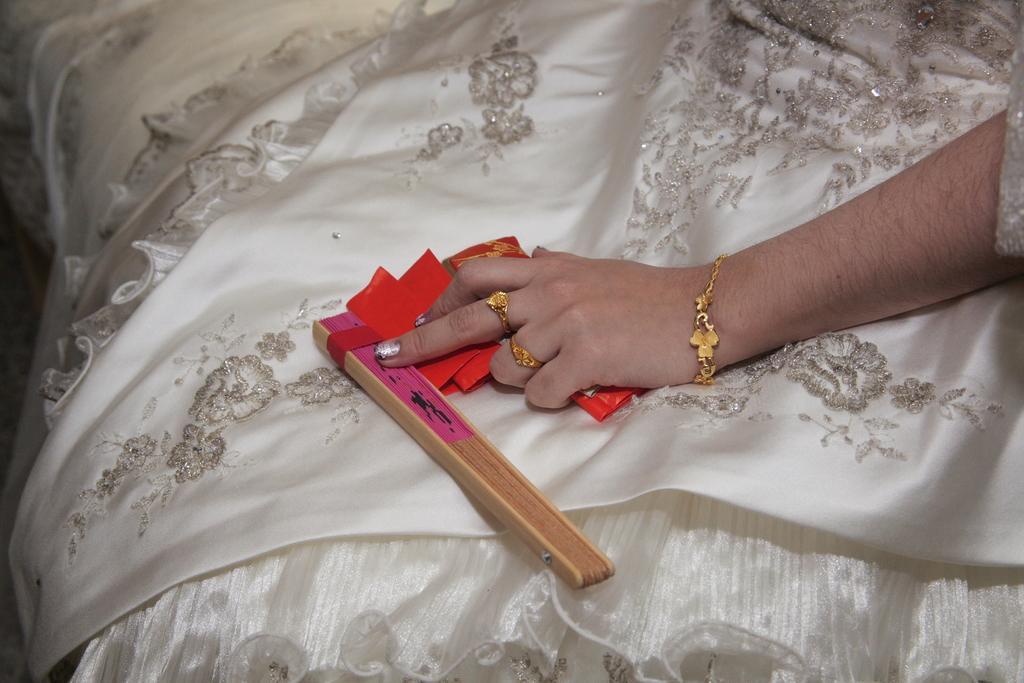Please provide a concise description of this image. This picture shows a wooden stick and we see few papers in the women's hand. We see couple of rings and a bracelet. She wore a white color dress with some design on it. 